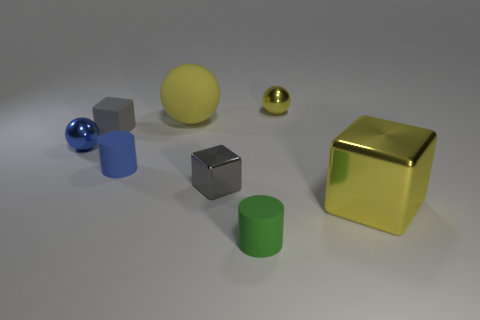How many small objects are either green objects or blue cylinders?
Provide a short and direct response. 2. How many tiny gray blocks are there?
Ensure brevity in your answer.  2. What is the material of the tiny object that is behind the matte cube?
Keep it short and to the point. Metal. Are there any tiny green cylinders on the right side of the big yellow cube?
Ensure brevity in your answer.  No. Do the gray matte cube and the yellow cube have the same size?
Ensure brevity in your answer.  No. How many yellow balls have the same material as the tiny blue ball?
Make the answer very short. 1. There is a yellow metal object that is in front of the blue metal ball that is behind the small metal block; what is its size?
Give a very brief answer. Large. What is the color of the rubber thing that is in front of the tiny matte block and left of the big yellow ball?
Give a very brief answer. Blue. Is the shape of the green rubber thing the same as the small gray matte thing?
Your response must be concise. No. The shiny sphere that is the same color as the big metal cube is what size?
Offer a terse response. Small. 